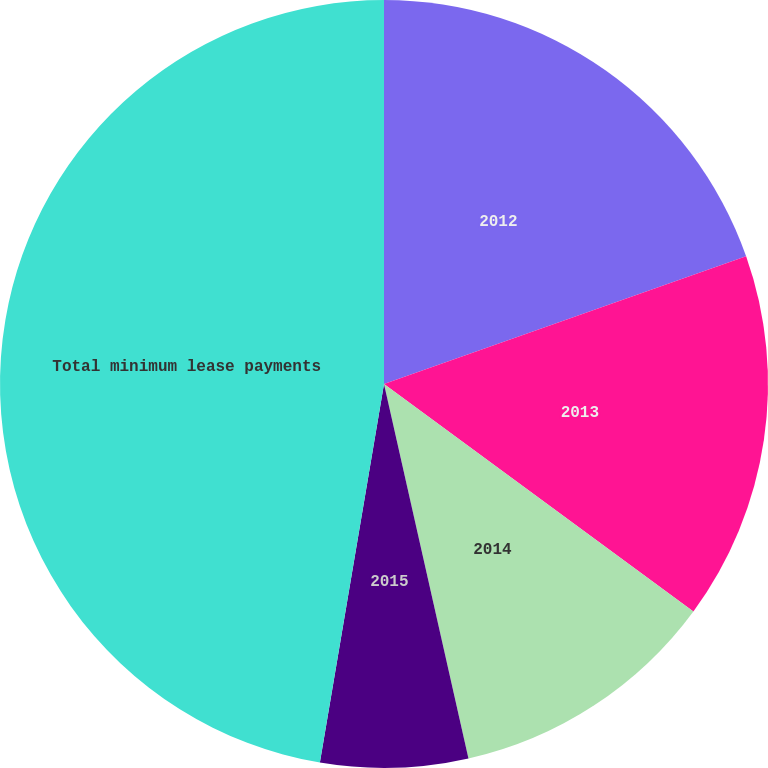Convert chart to OTSL. <chart><loc_0><loc_0><loc_500><loc_500><pie_chart><fcel>2012<fcel>2013<fcel>2014<fcel>2015<fcel>Total minimum lease payments<nl><fcel>19.6%<fcel>15.49%<fcel>11.38%<fcel>6.2%<fcel>47.33%<nl></chart> 